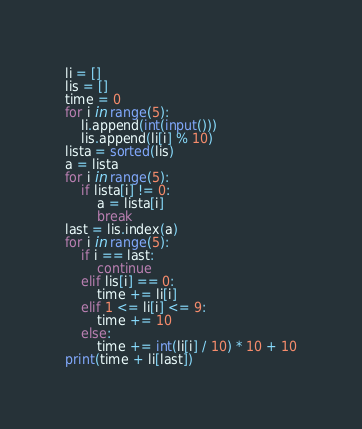<code> <loc_0><loc_0><loc_500><loc_500><_Python_>li = []
lis = []
time = 0
for i in range(5):
    li.append(int(input()))
    lis.append(li[i] % 10)
lista = sorted(lis)
a = lista
for i in range(5):
    if lista[i] != 0:
        a = lista[i]
        break
last = lis.index(a)
for i in range(5):
    if i == last:
        continue
    elif lis[i] == 0:
        time += li[i]
    elif 1 <= li[i] <= 9:
        time += 10
    else:
        time += int(li[i] / 10) * 10 + 10
print(time + li[last])</code> 